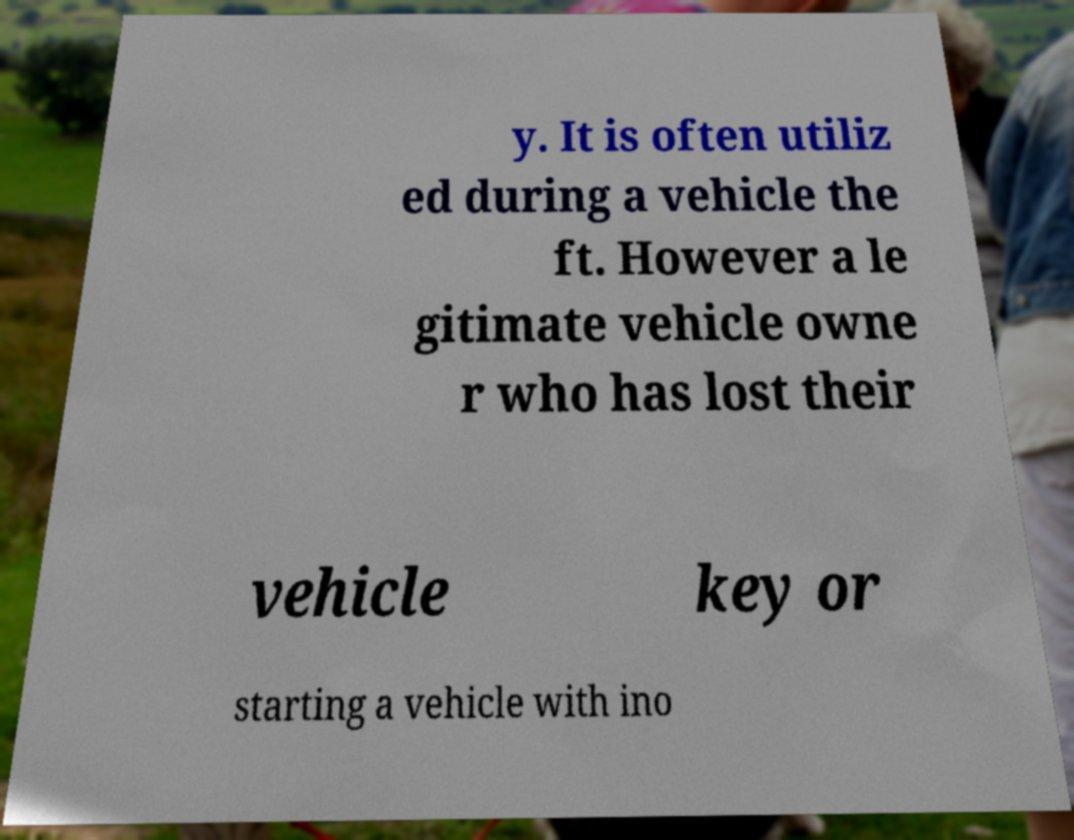Can you read and provide the text displayed in the image?This photo seems to have some interesting text. Can you extract and type it out for me? y. It is often utiliz ed during a vehicle the ft. However a le gitimate vehicle owne r who has lost their vehicle key or starting a vehicle with ino 